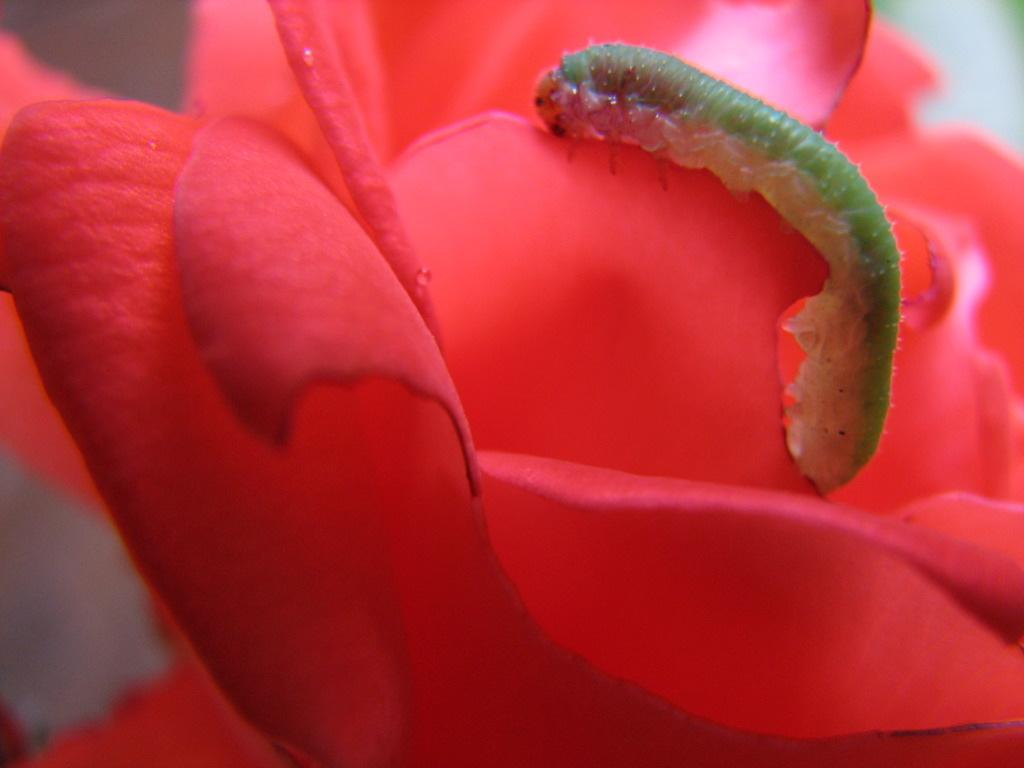What is the main subject of the image? The main subject of the image is a green color caterpillar. Where is the caterpillar located in the image? The caterpillar is on the petal of a red color flower. Can you describe the background of the image? The background of the image is blurry. What type of interest does the queen have in the caterpillar in the image? There is no queen present in the image, and therefore no interest in the caterpillar can be determined. 